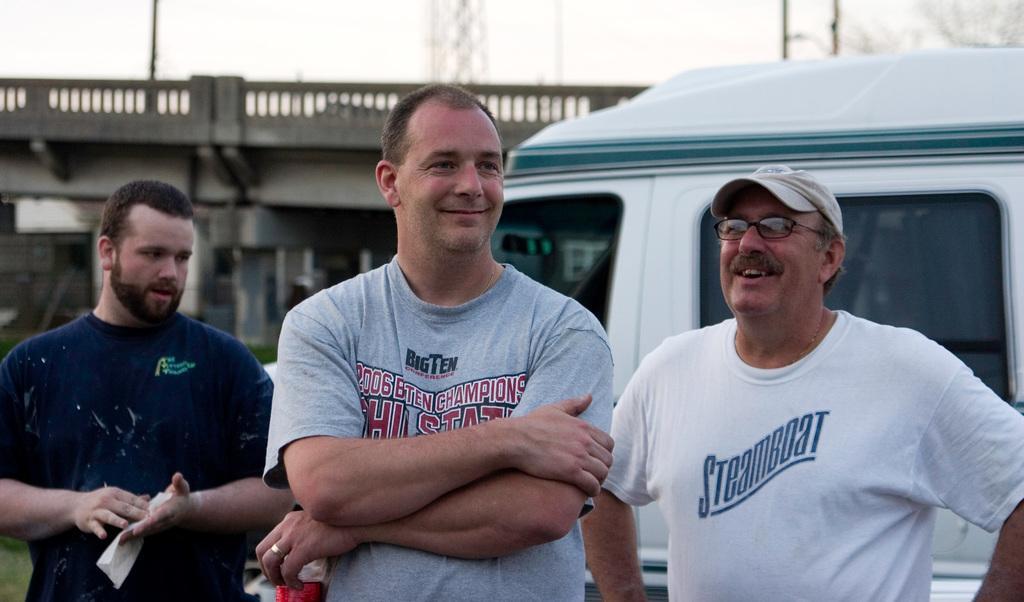Can you describe this image briefly? In this picture I can see there are three persons standing here and the person on the right side is wearing a white color shirt and a cap and the person in middle is wearing a grey shirt and the person on to left is wearing a blue shirt and in the backdrop there is a truck and a building and the sky is clear. 